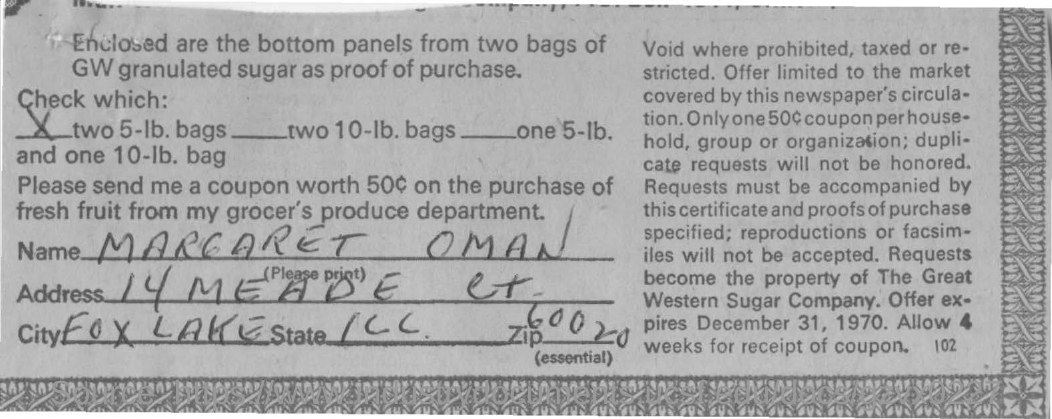What is the name written in the form ?
Keep it short and to the point. MARGARET OMAN. What is the name of the city mentioned ?
Provide a succinct answer. Fox lake. What is the zip number written ?
Your response must be concise. 60020. 